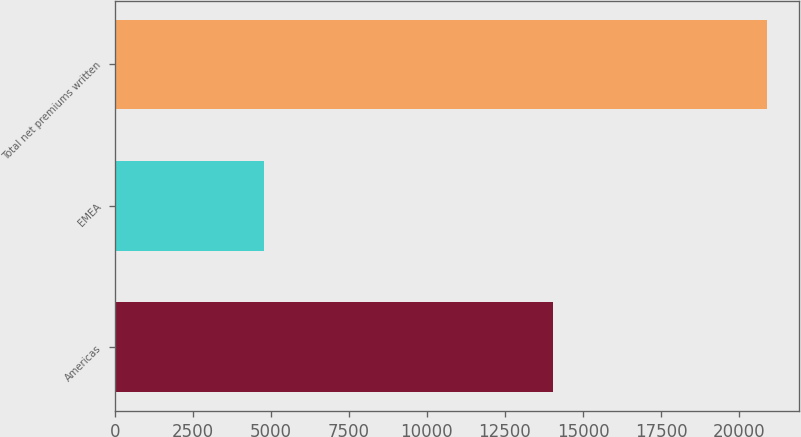Convert chart. <chart><loc_0><loc_0><loc_500><loc_500><bar_chart><fcel>Americas<fcel>EMEA<fcel>Total net premiums written<nl><fcel>14050<fcel>4795<fcel>20880<nl></chart> 